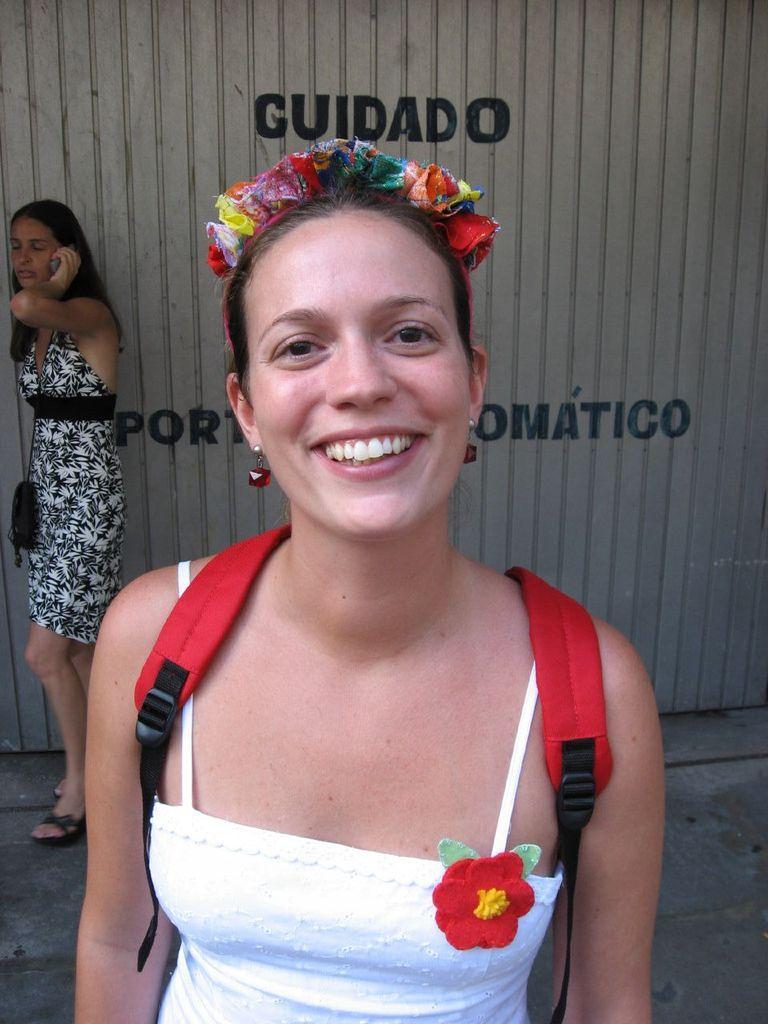In one or two sentences, can you explain what this image depicts? In this image we can see a woman wearing the bag and smiling. In the background we can see other women wearing the bag and holding the phone and standing on the path. We can also see the text on the wall. 